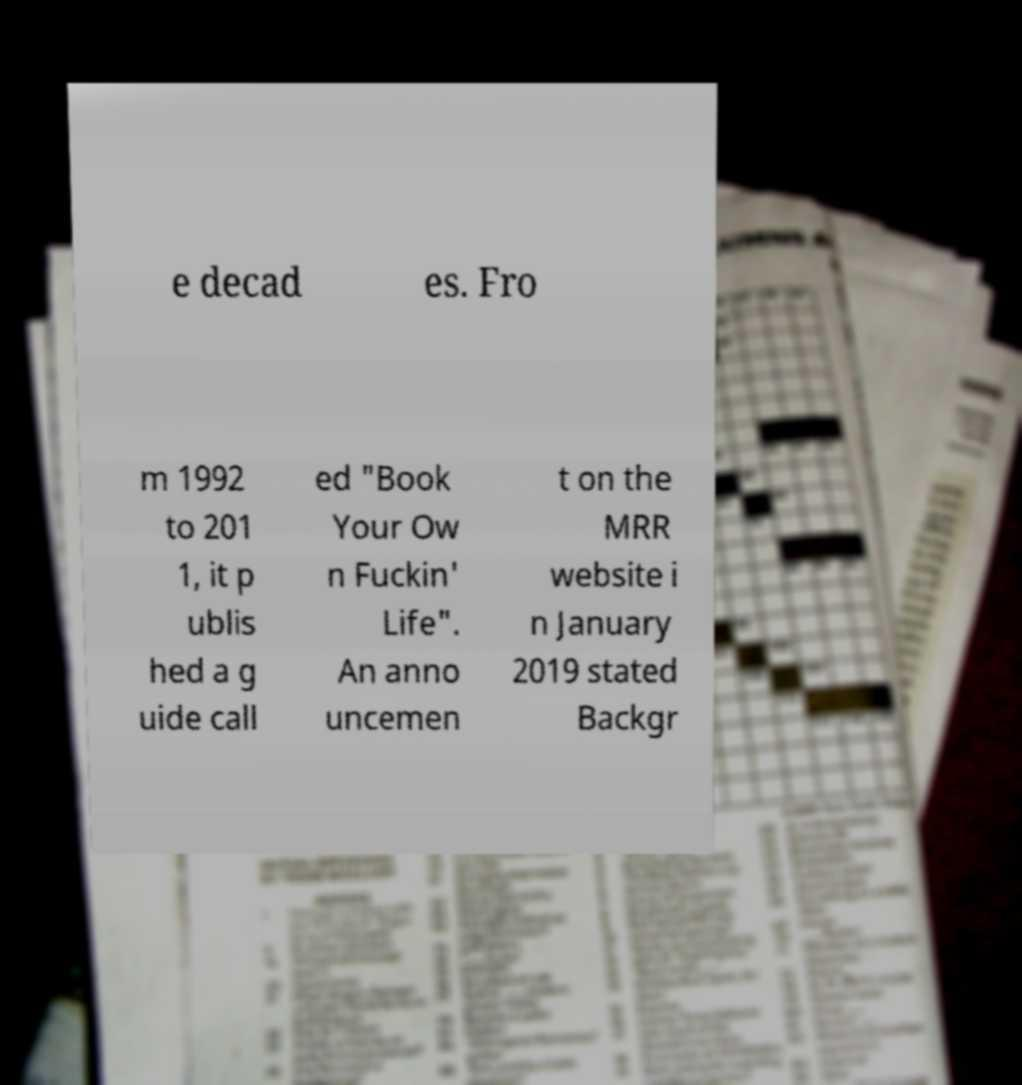I need the written content from this picture converted into text. Can you do that? e decad es. Fro m 1992 to 201 1, it p ublis hed a g uide call ed "Book Your Ow n Fuckin' Life". An anno uncemen t on the MRR website i n January 2019 stated Backgr 